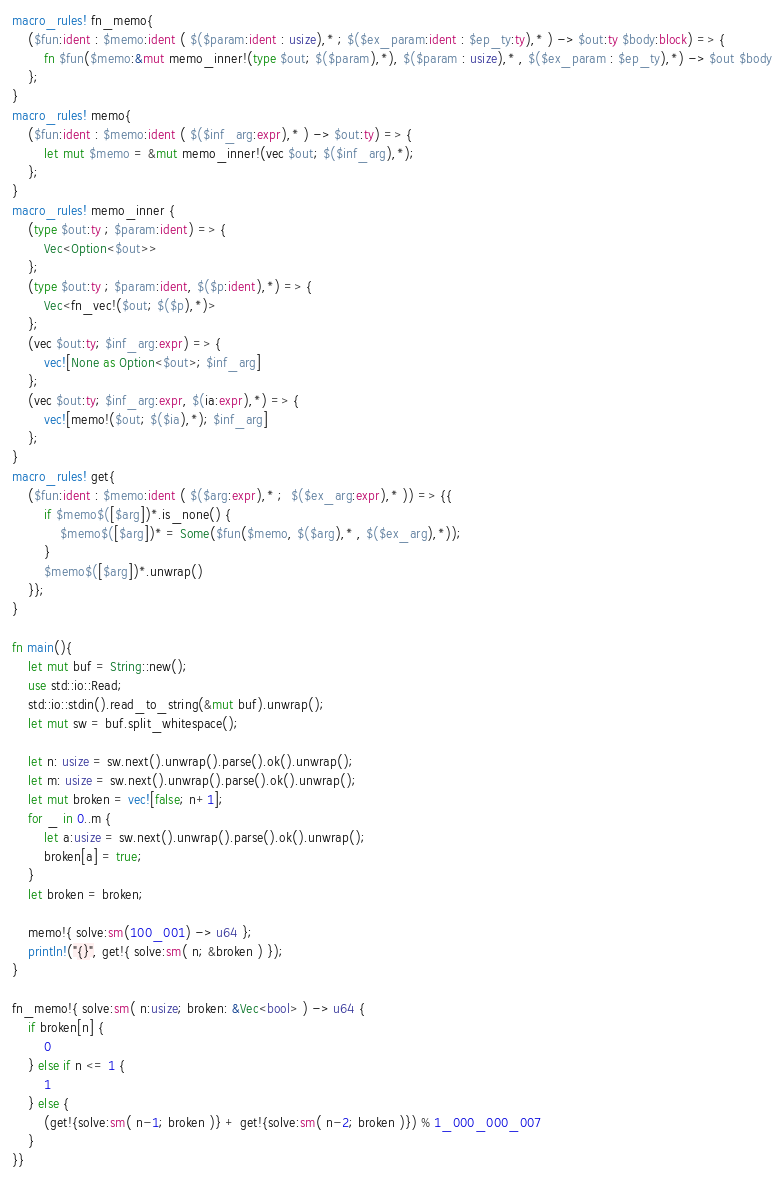<code> <loc_0><loc_0><loc_500><loc_500><_Rust_>
macro_rules! fn_memo{
    ($fun:ident : $memo:ident ( $($param:ident : usize),* ; $($ex_param:ident : $ep_ty:ty),* ) -> $out:ty $body:block) => {
        fn $fun($memo:&mut memo_inner!(type $out; $($param),*), $($param : usize),* , $($ex_param : $ep_ty),*) -> $out $body
    };
}
macro_rules! memo{
    ($fun:ident : $memo:ident ( $($inf_arg:expr),* ) -> $out:ty) => {
        let mut $memo = &mut memo_inner!(vec $out; $($inf_arg),*);
    };
}
macro_rules! memo_inner {
    (type $out:ty ; $param:ident) => {
        Vec<Option<$out>>
    };
    (type $out:ty ; $param:ident, $($p:ident),*) => {
        Vec<fn_vec!($out; $($p),*)>
    };
    (vec $out:ty; $inf_arg:expr) => {
        vec![None as Option<$out>; $inf_arg]
    };
    (vec $out:ty; $inf_arg:expr, $(ia:expr),*) => {
        vec![memo!($out; $($ia),*); $inf_arg]
    };
}
macro_rules! get{
    ($fun:ident : $memo:ident ( $($arg:expr),* ;  $($ex_arg:expr),* )) => {{
        if $memo$([$arg])*.is_none() {
            $memo$([$arg])* = Some($fun($memo, $($arg),* , $($ex_arg),*));
        }
        $memo$([$arg])*.unwrap()
    }};
}

fn main(){
    let mut buf = String::new();
    use std::io::Read;
    std::io::stdin().read_to_string(&mut buf).unwrap();
    let mut sw = buf.split_whitespace();
    
    let n: usize = sw.next().unwrap().parse().ok().unwrap();
    let m: usize = sw.next().unwrap().parse().ok().unwrap();
    let mut broken = vec![false; n+1];
    for _ in 0..m {
        let a:usize = sw.next().unwrap().parse().ok().unwrap();
        broken[a] = true;
    }
    let broken = broken;
    
    memo!{ solve:sm(100_001) -> u64 };
    println!("{}", get!{ solve:sm( n; &broken ) });
}

fn_memo!{ solve:sm( n:usize; broken: &Vec<bool> ) -> u64 {
    if broken[n] {
        0
    } else if n <= 1 { 
        1
    } else {
        (get!{solve:sm( n-1; broken )} + get!{solve:sm( n-2; broken )}) % 1_000_000_007
    }
}}

</code> 